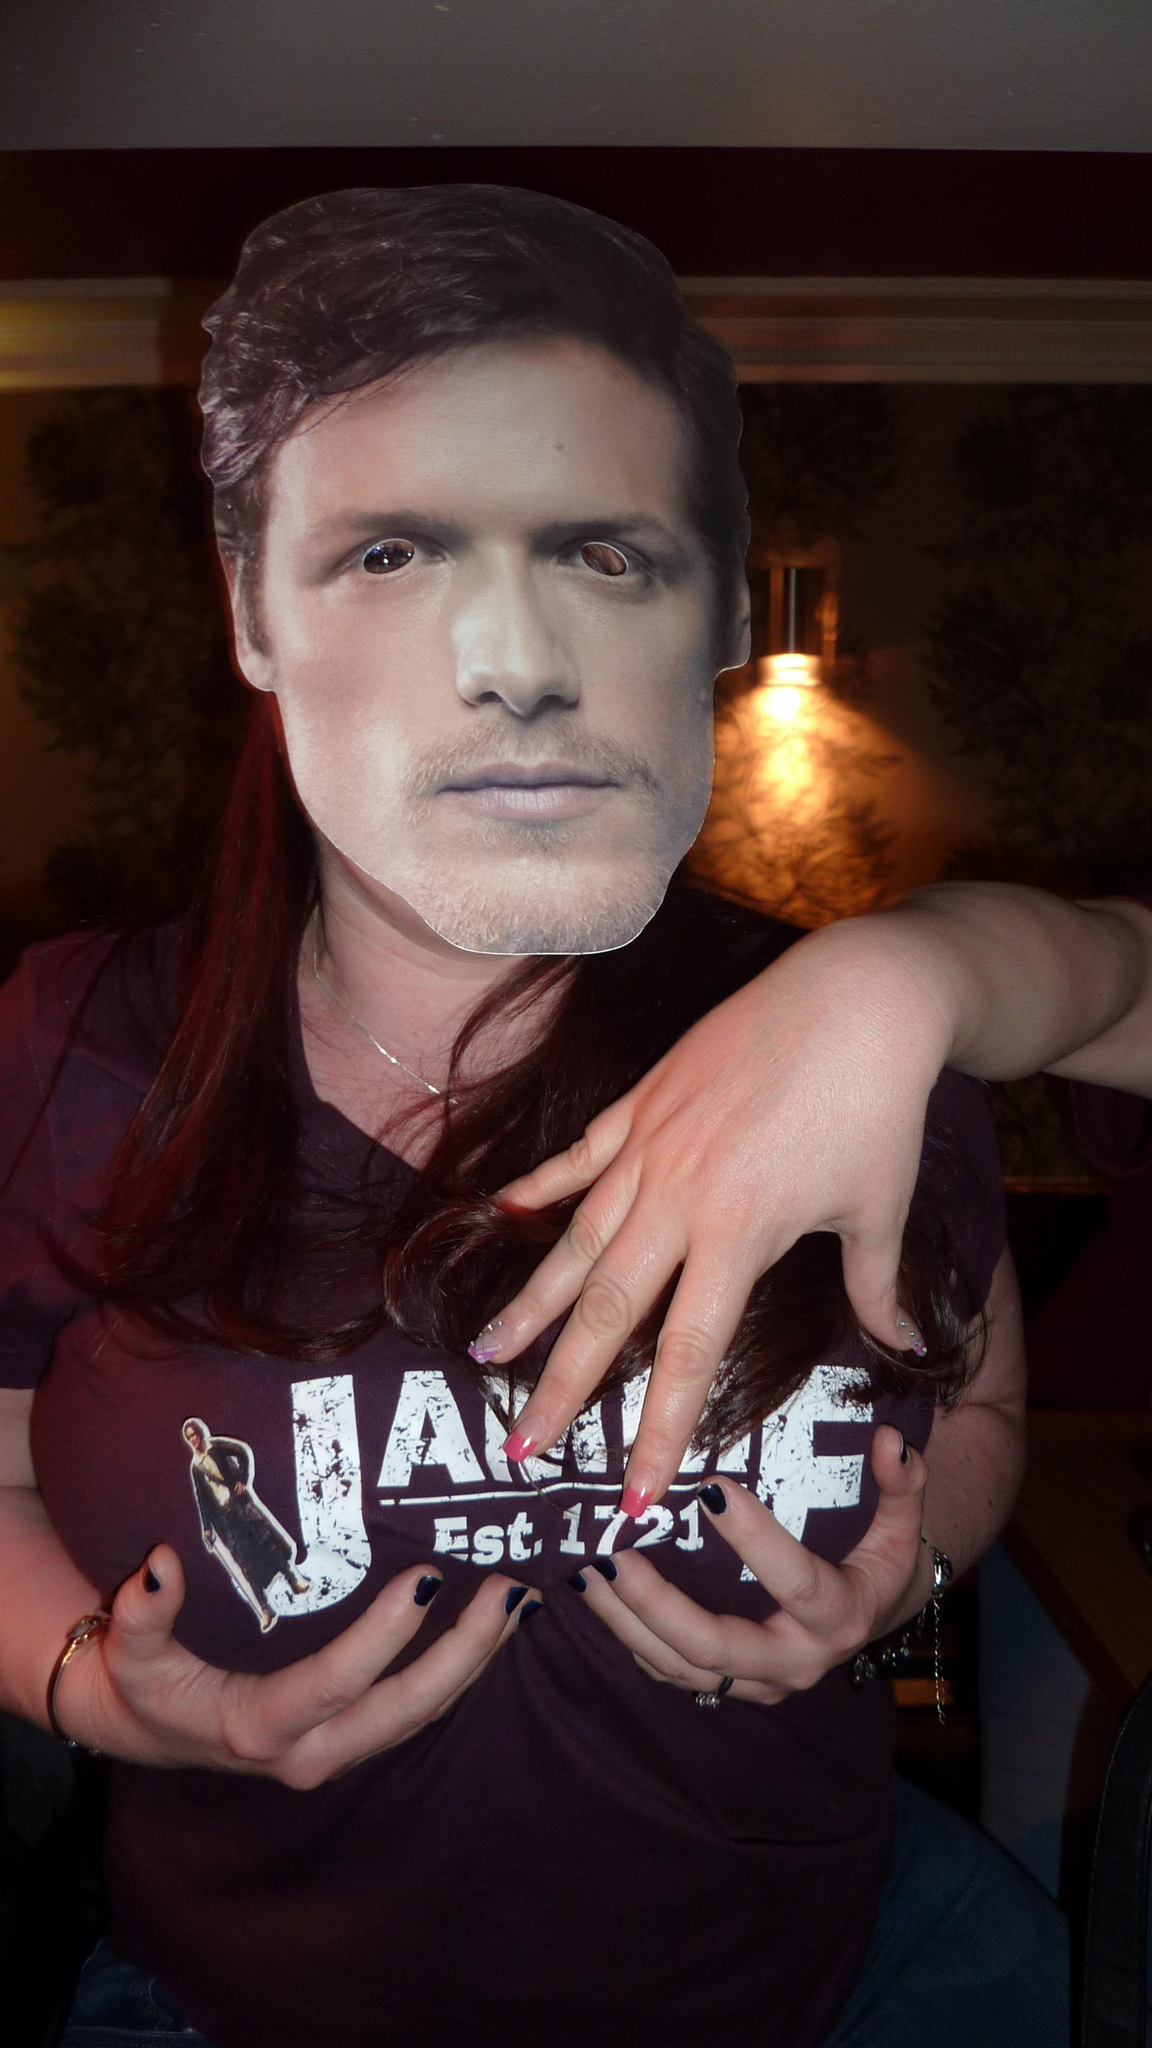Who or what is present in the image? There is a person in the image. What is the person wearing on their face? The person is wearing a mask. What color is the T-shirt the person is wearing? The person is wearing a brown color T-shirt. Reasoning: Let' Let's think step by step in order to produce the conversation. We start by identifying the main subject in the image, which is the person. Then, we describe the person's appearance, focusing on the mask and the color of their T-shirt. Each question is designed to elicit a specific detail about the image that is known from the provided facts. Absurd Question/Answer: How many beds can be seen in the image? There are no beds present in the image. What type of idea is being expressed by the person in the image? The image does not convey any ideas or expressions; it only shows a person wearing a mask and a brown T-shirt. Is there a spring season depicted in the image? There is no indication of a season or weather in the image; it only shows a person wearing a mask and a brown T-shirt. 